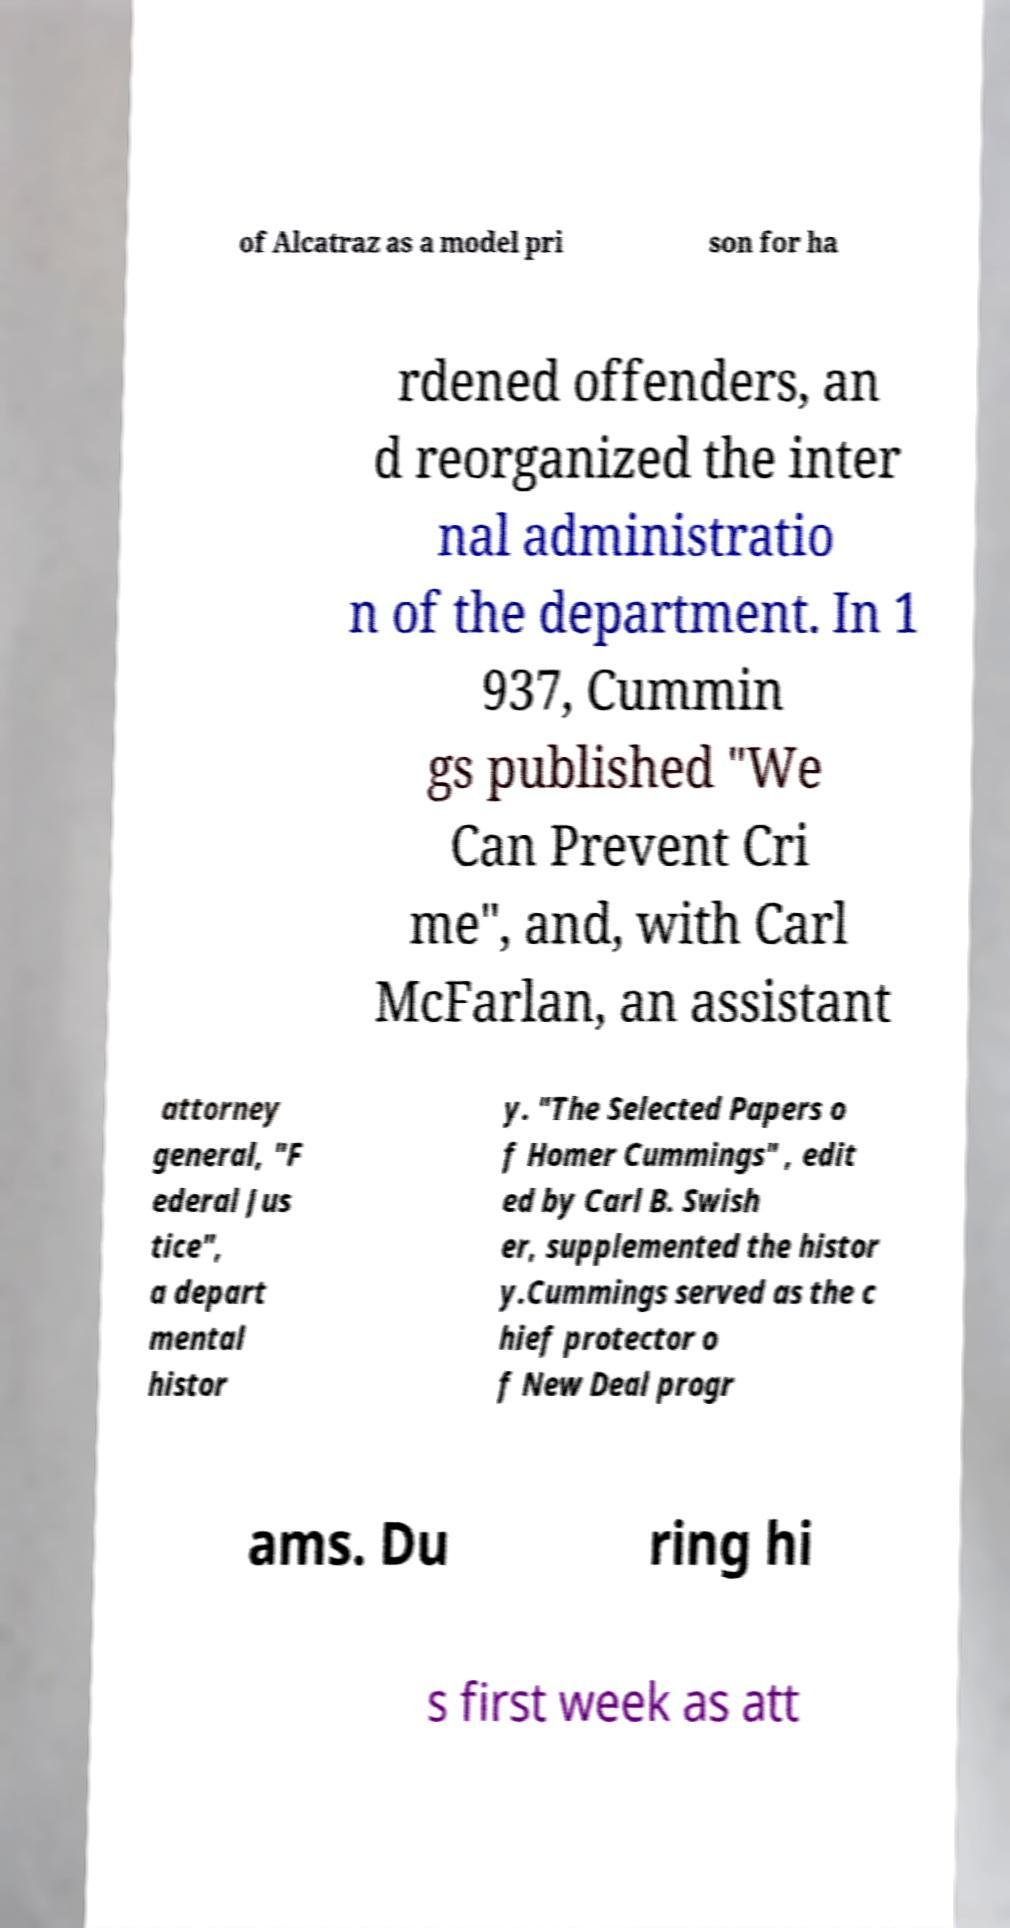Please identify and transcribe the text found in this image. of Alcatraz as a model pri son for ha rdened offenders, an d reorganized the inter nal administratio n of the department. In 1 937, Cummin gs published "We Can Prevent Cri me", and, with Carl McFarlan, an assistant attorney general, "F ederal Jus tice", a depart mental histor y. "The Selected Papers o f Homer Cummings" , edit ed by Carl B. Swish er, supplemented the histor y.Cummings served as the c hief protector o f New Deal progr ams. Du ring hi s first week as att 